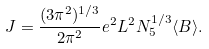Convert formula to latex. <formula><loc_0><loc_0><loc_500><loc_500>J = \frac { ( 3 \pi ^ { 2 } ) ^ { 1 / 3 } } { 2 \pi ^ { 2 } } e ^ { 2 } L ^ { 2 } N _ { 5 } ^ { 1 / 3 } \langle B \rangle .</formula> 